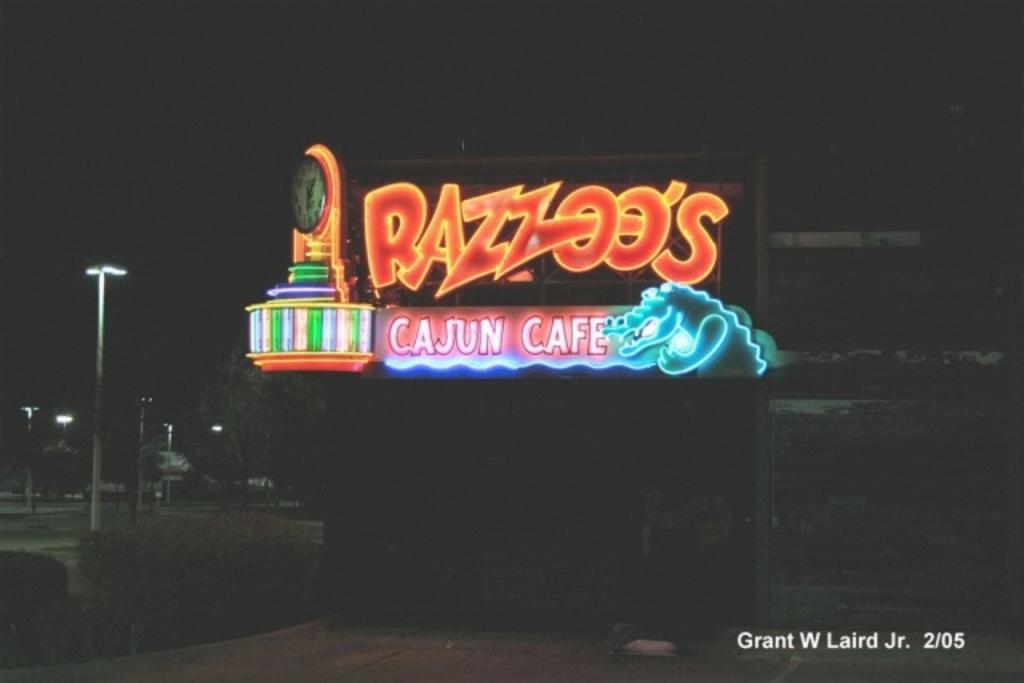<image>
Give a short and clear explanation of the subsequent image. A neon sign for Razzoo's Cajun Cafe lit up in the night. 